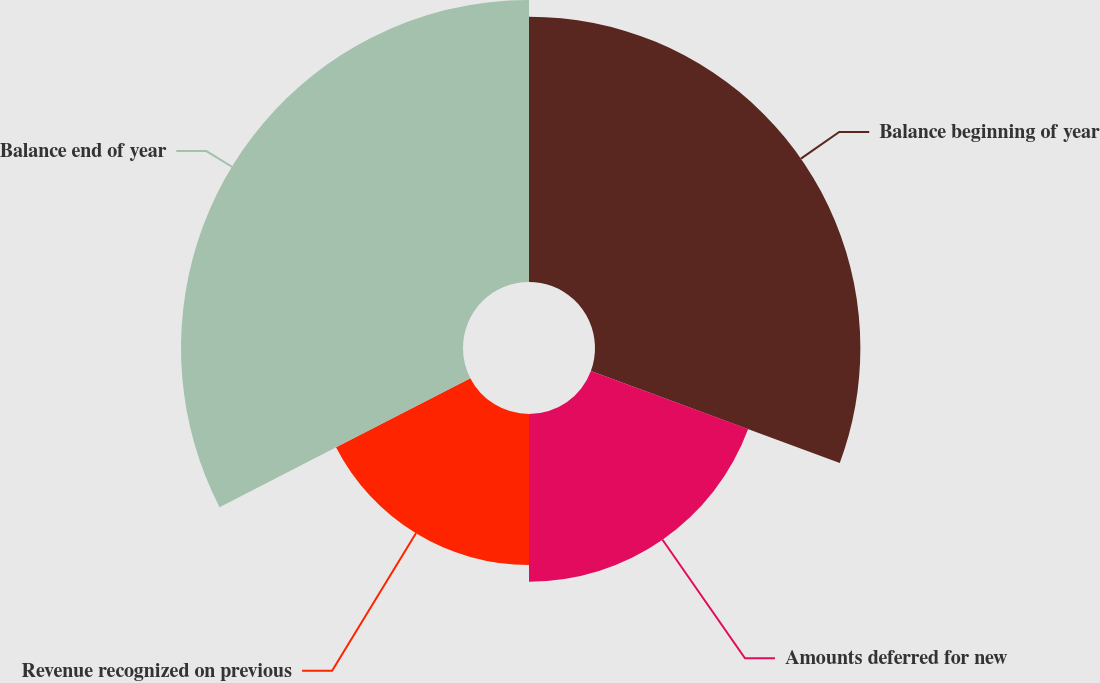<chart> <loc_0><loc_0><loc_500><loc_500><pie_chart><fcel>Balance beginning of year<fcel>Amounts deferred for new<fcel>Revenue recognized on previous<fcel>Balance end of year<nl><fcel>30.64%<fcel>19.36%<fcel>17.44%<fcel>32.56%<nl></chart> 